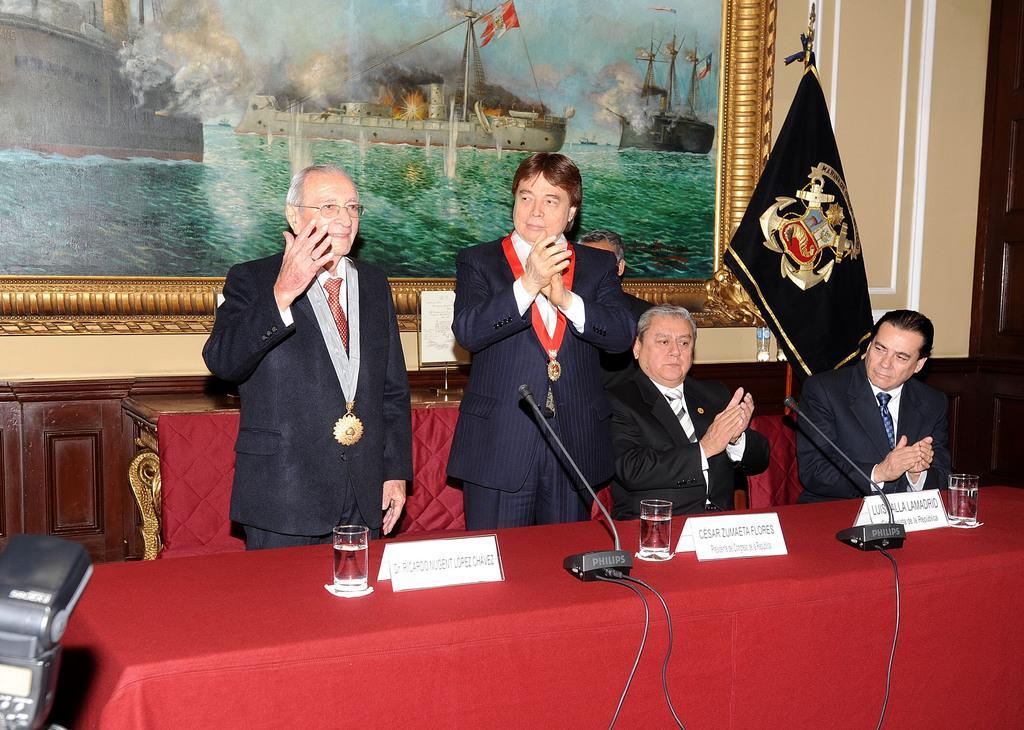Could you give a brief overview of what you see in this image? In this image I can see two persons wearing white shirt and black blazer are standing and two other persons are sitting on chairs which are red in color. I can see a table in front of them which is red in color and on the table I can see few glasses, few boards and two microphones. In the background I can see the cream colored wall, a photo frame attached to the wall and to the left bottom of the image I can see a camera. 